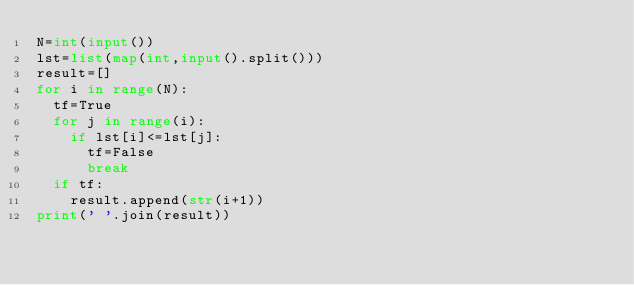Convert code to text. <code><loc_0><loc_0><loc_500><loc_500><_Python_>N=int(input())
lst=list(map(int,input().split()))
result=[]
for i in range(N):
  tf=True
  for j in range(i):
    if lst[i]<=lst[j]:
      tf=False
      break
  if tf:
    result.append(str(i+1))
print(' '.join(result))</code> 